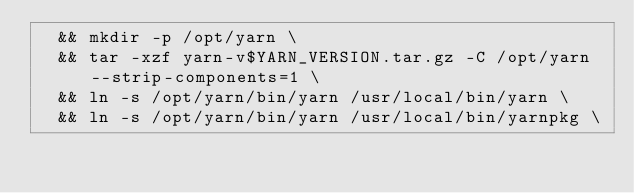<code> <loc_0><loc_0><loc_500><loc_500><_Dockerfile_>	&& mkdir -p /opt/yarn \
	&& tar -xzf yarn-v$YARN_VERSION.tar.gz -C /opt/yarn --strip-components=1 \
	&& ln -s /opt/yarn/bin/yarn /usr/local/bin/yarn \
	&& ln -s /opt/yarn/bin/yarn /usr/local/bin/yarnpkg \</code> 